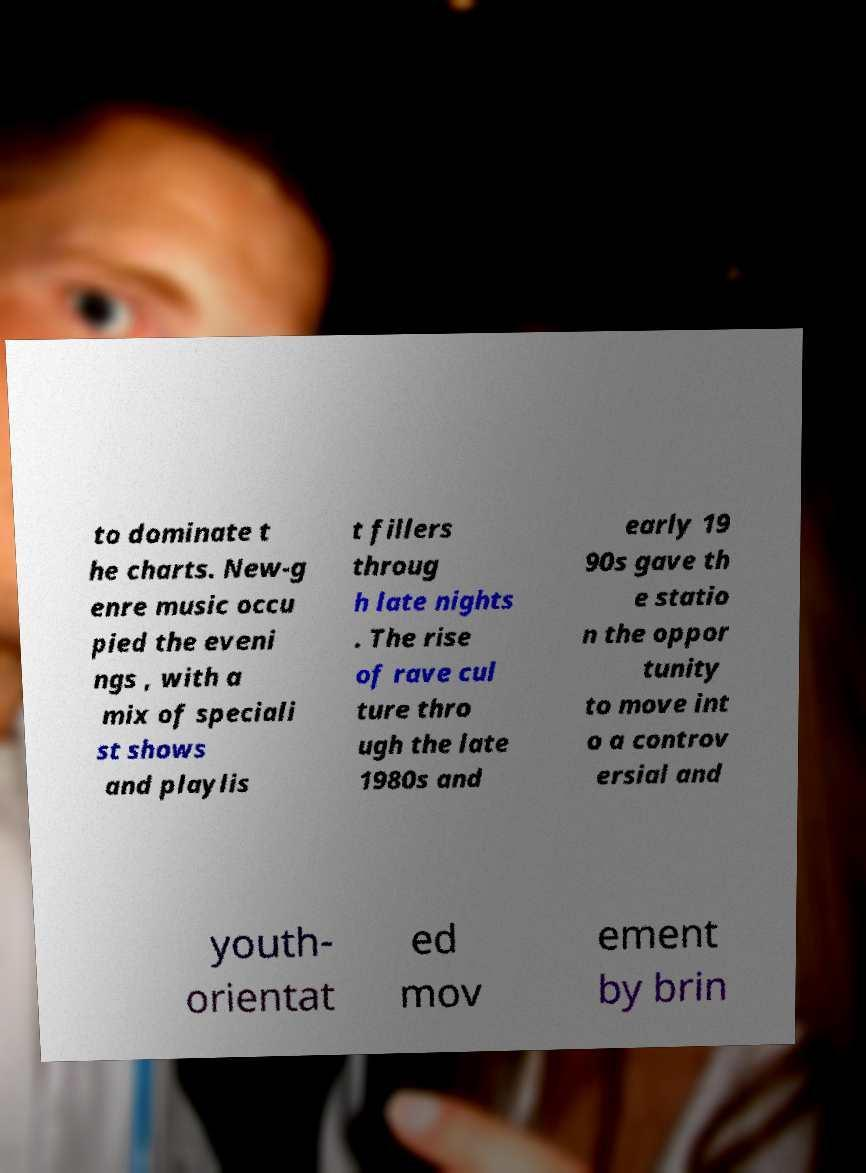What messages or text are displayed in this image? I need them in a readable, typed format. to dominate t he charts. New-g enre music occu pied the eveni ngs , with a mix of speciali st shows and playlis t fillers throug h late nights . The rise of rave cul ture thro ugh the late 1980s and early 19 90s gave th e statio n the oppor tunity to move int o a controv ersial and youth- orientat ed mov ement by brin 